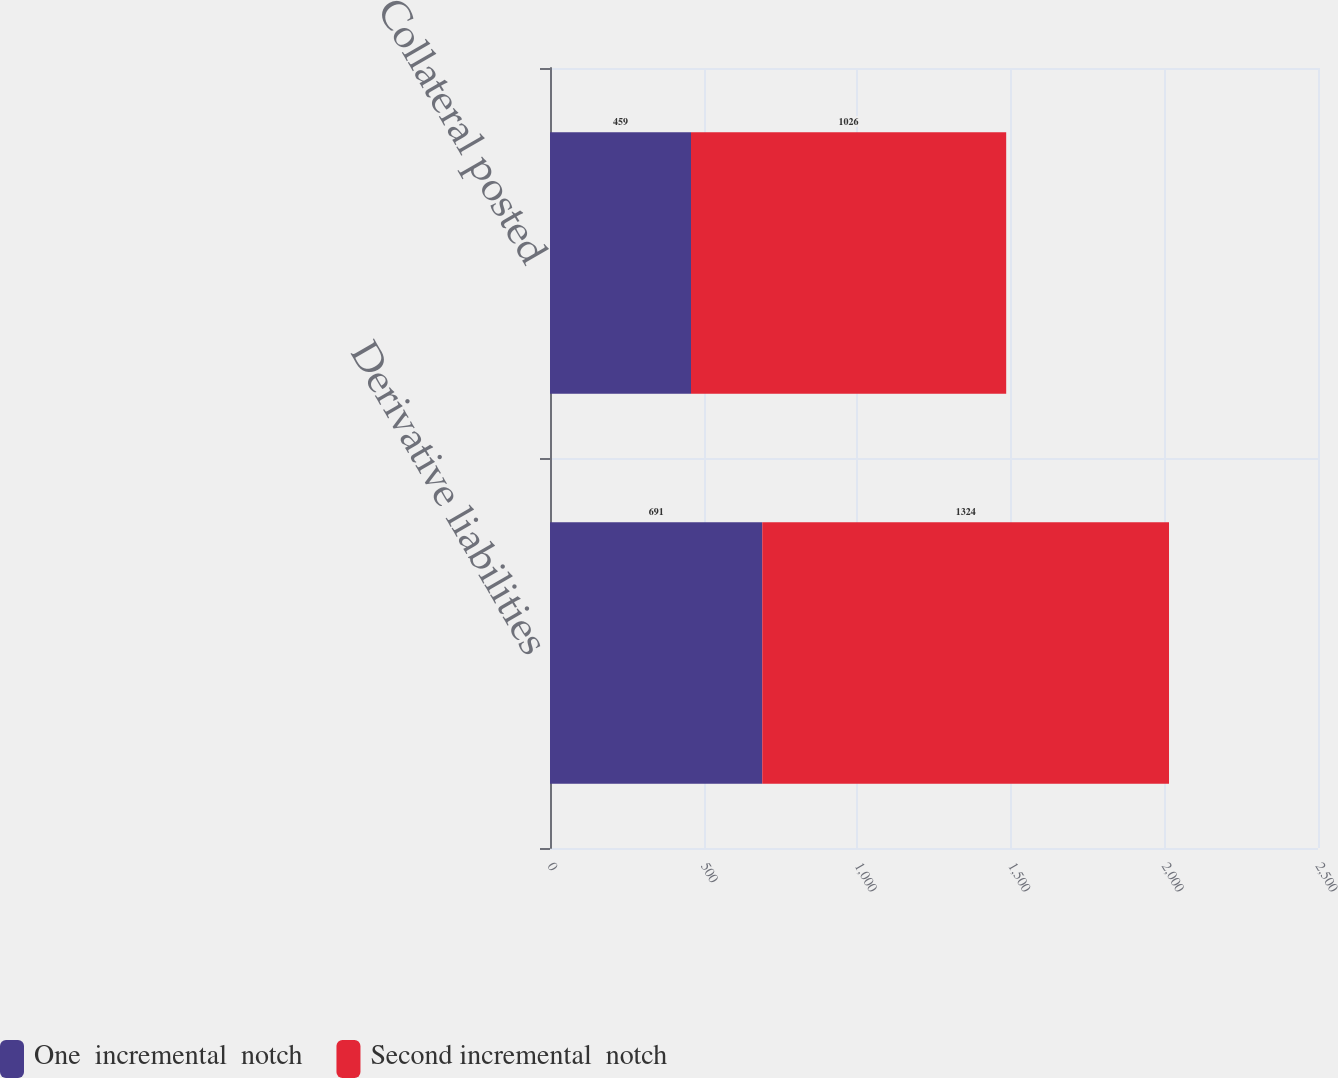Convert chart. <chart><loc_0><loc_0><loc_500><loc_500><stacked_bar_chart><ecel><fcel>Derivative liabilities<fcel>Collateral posted<nl><fcel>One  incremental  notch<fcel>691<fcel>459<nl><fcel>Second incremental  notch<fcel>1324<fcel>1026<nl></chart> 